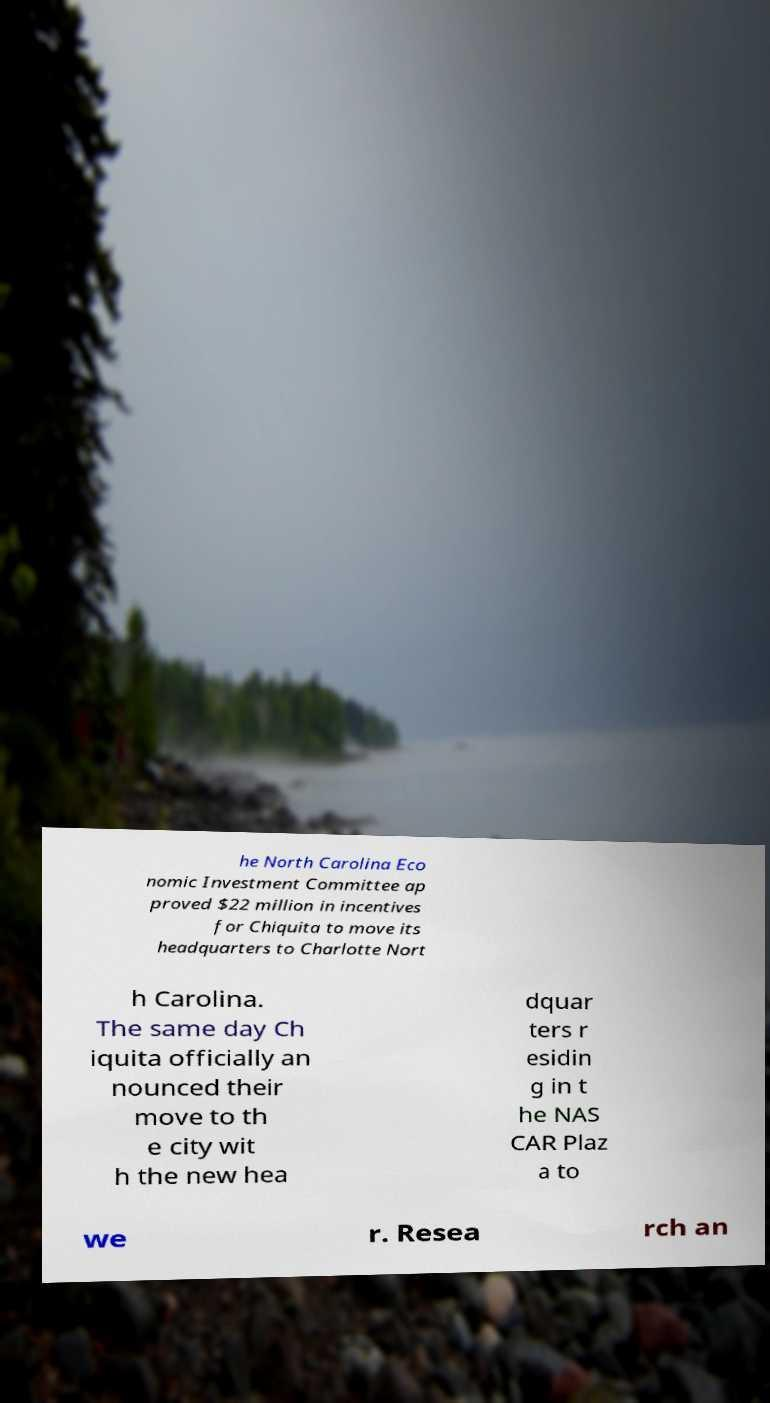Could you assist in decoding the text presented in this image and type it out clearly? he North Carolina Eco nomic Investment Committee ap proved $22 million in incentives for Chiquita to move its headquarters to Charlotte Nort h Carolina. The same day Ch iquita officially an nounced their move to th e city wit h the new hea dquar ters r esidin g in t he NAS CAR Plaz a to we r. Resea rch an 